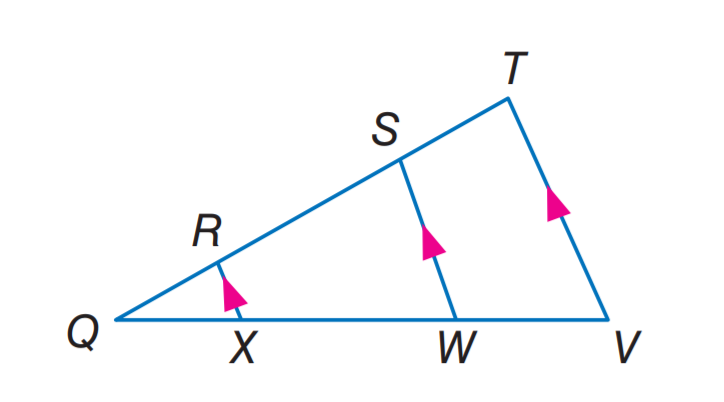Question: If Q R = 2, X W = 12, Q W = 15, and S T = 5, find W V.
Choices:
A. 5
B. 7.5
C. 8
D. 12
Answer with the letter. Answer: B Question: If Q R = 2, X W = 12, Q W = 15, and S T = 5, find R S.
Choices:
A. 5
B. 7.5
C. 8
D. 12
Answer with the letter. Answer: C 